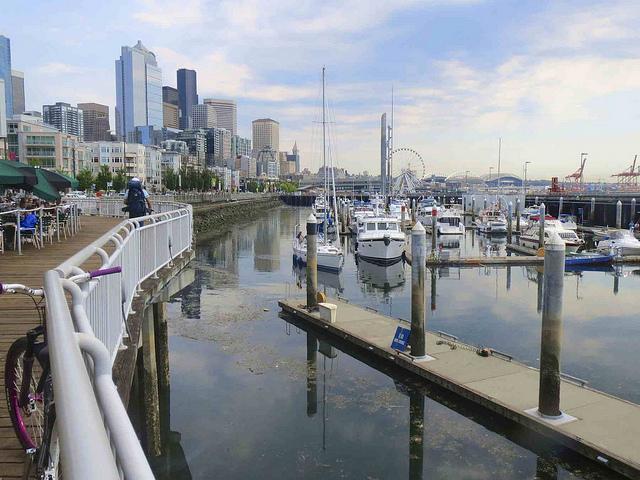What area is shown here?
Pick the correct solution from the four options below to address the question.
Options: City highway, race track, bike path, harbor. Harbor. 